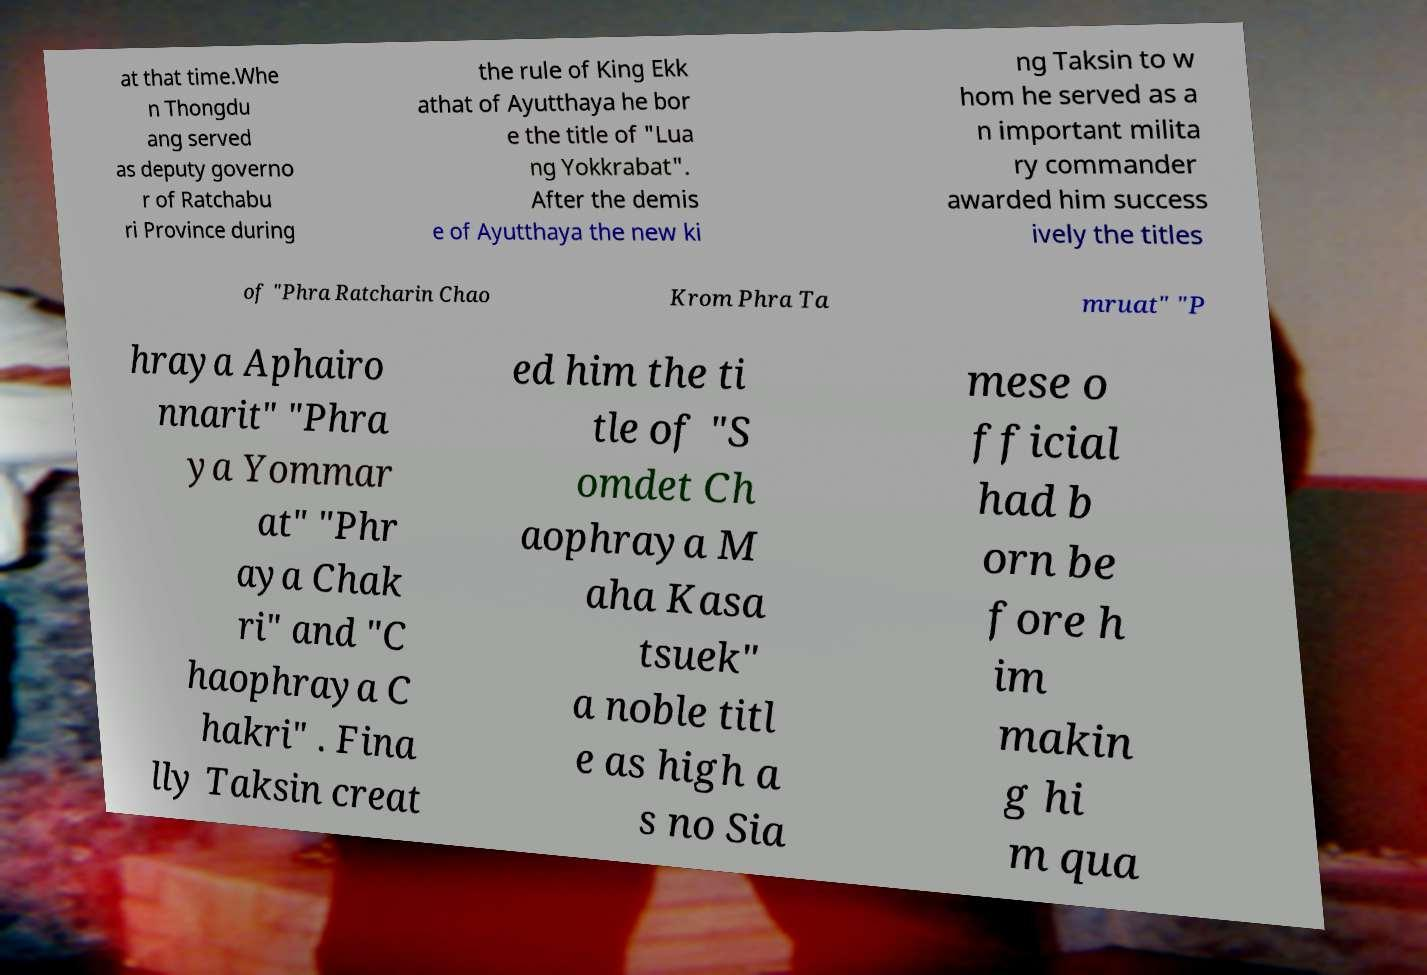I need the written content from this picture converted into text. Can you do that? at that time.Whe n Thongdu ang served as deputy governo r of Ratchabu ri Province during the rule of King Ekk athat of Ayutthaya he bor e the title of "Lua ng Yokkrabat". After the demis e of Ayutthaya the new ki ng Taksin to w hom he served as a n important milita ry commander awarded him success ively the titles of "Phra Ratcharin Chao Krom Phra Ta mruat" "P hraya Aphairo nnarit" "Phra ya Yommar at" "Phr aya Chak ri" and "C haophraya C hakri" . Fina lly Taksin creat ed him the ti tle of "S omdet Ch aophraya M aha Kasa tsuek" a noble titl e as high a s no Sia mese o fficial had b orn be fore h im makin g hi m qua 